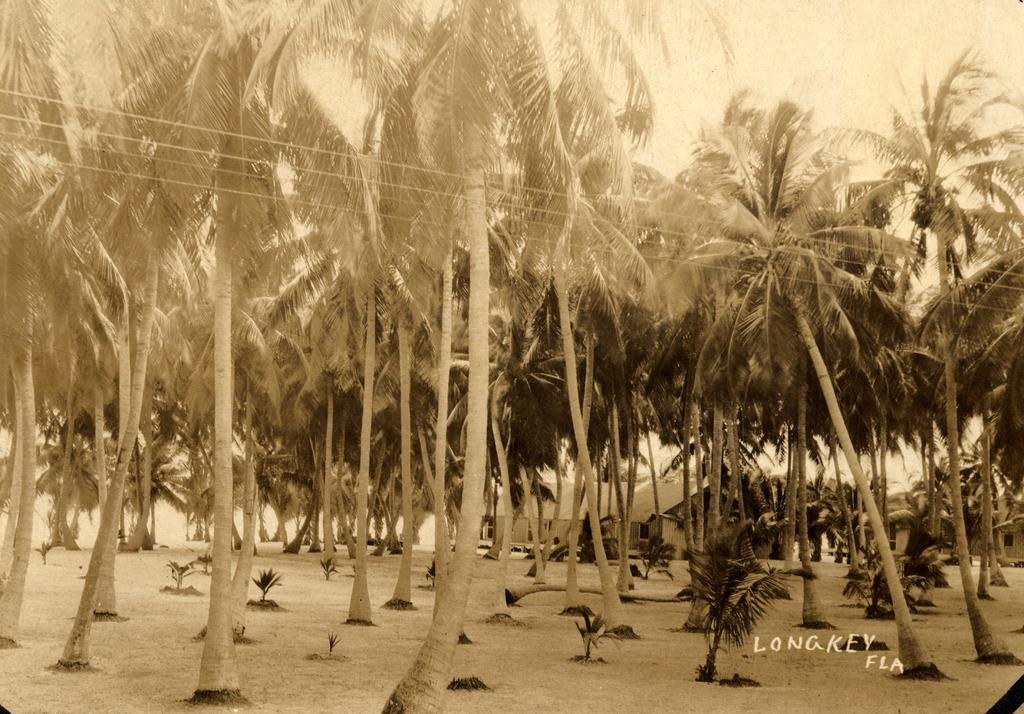What type of structures can be seen in the image? There are houses in the image. What other elements are present in the image besides houses? There are plants, wires, objects on the surface, text, and coconut trees in the image. What is visible at the top of the image? The sky is visible at the top of the image. Can you tell me how many bears are sitting on the wires in the image? There are no bears present in the image; it features houses, plants, wires, objects on the surface, text, and coconut trees. What is the name of the son who lives in one of the houses in the image? There is no information about the residents of the houses in the image, so it is not possible to determine the name of any son. 